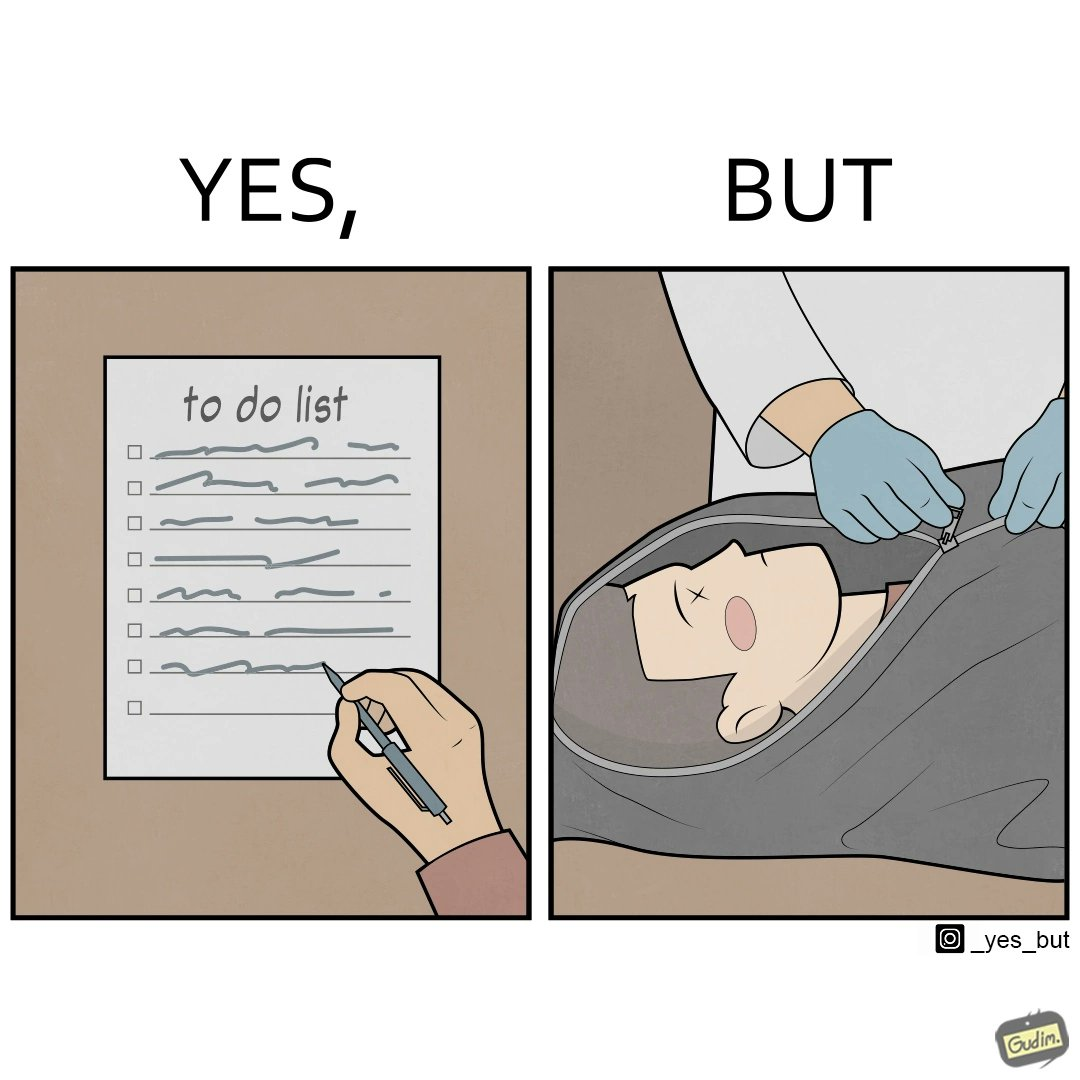Would you classify this image as satirical? Yes, this image is satirical. 